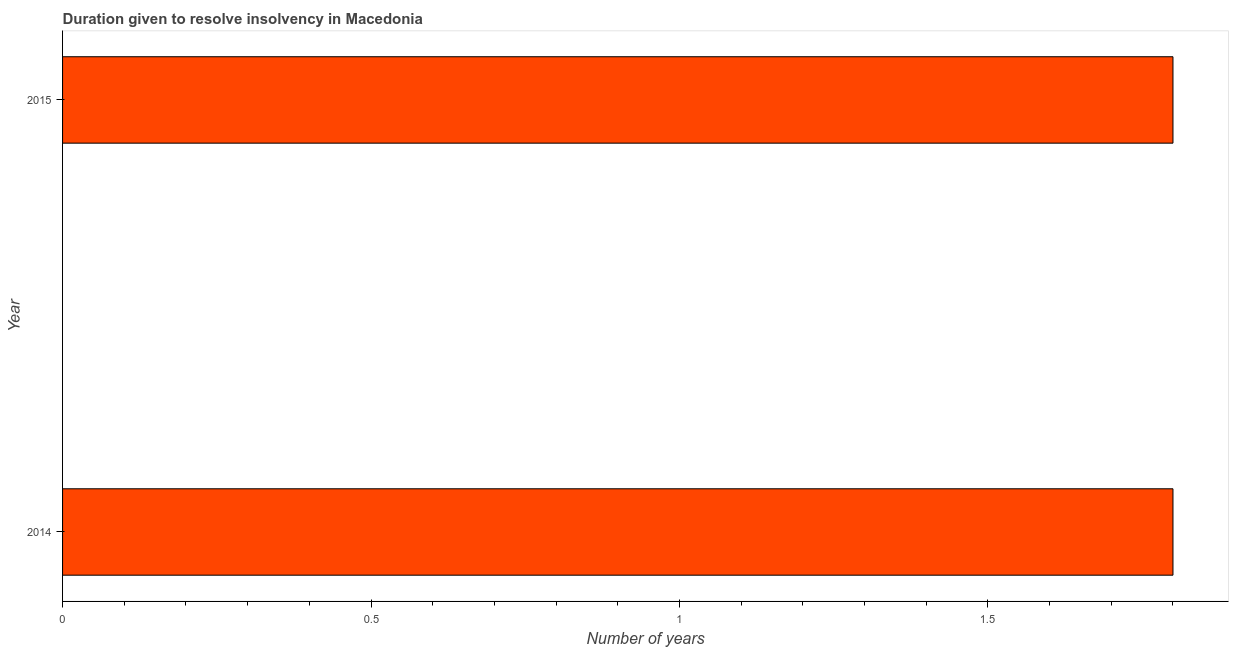Does the graph contain any zero values?
Your answer should be very brief. No. Does the graph contain grids?
Offer a terse response. No. What is the title of the graph?
Ensure brevity in your answer.  Duration given to resolve insolvency in Macedonia. What is the label or title of the X-axis?
Keep it short and to the point. Number of years. What is the number of years to resolve insolvency in 2014?
Provide a succinct answer. 1.8. Across all years, what is the maximum number of years to resolve insolvency?
Your answer should be compact. 1.8. In which year was the number of years to resolve insolvency maximum?
Your answer should be very brief. 2014. What is the difference between the number of years to resolve insolvency in 2014 and 2015?
Offer a terse response. 0. What is the median number of years to resolve insolvency?
Make the answer very short. 1.8. In how many years, is the number of years to resolve insolvency greater than 0.9 ?
Ensure brevity in your answer.  2. What is the ratio of the number of years to resolve insolvency in 2014 to that in 2015?
Give a very brief answer. 1. In how many years, is the number of years to resolve insolvency greater than the average number of years to resolve insolvency taken over all years?
Keep it short and to the point. 0. How many bars are there?
Keep it short and to the point. 2. Are all the bars in the graph horizontal?
Offer a very short reply. Yes. Are the values on the major ticks of X-axis written in scientific E-notation?
Provide a succinct answer. No. 